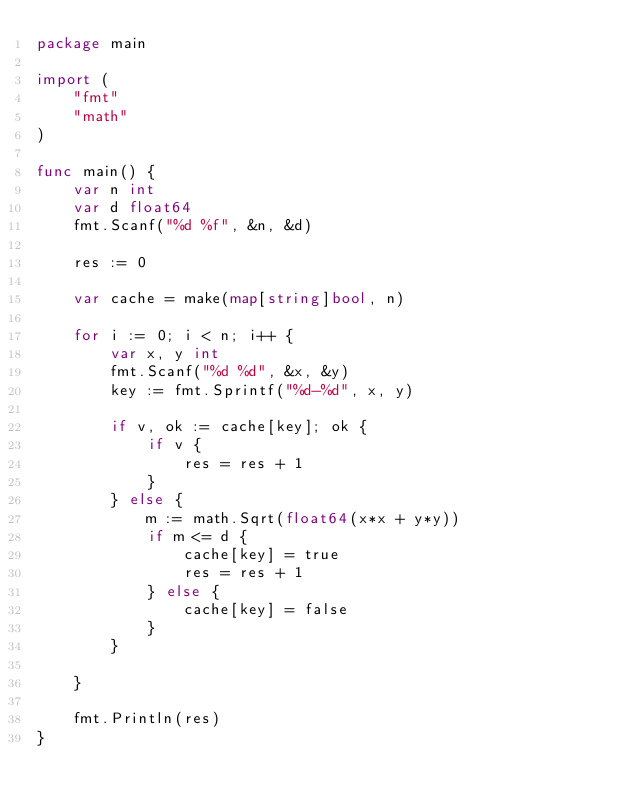Convert code to text. <code><loc_0><loc_0><loc_500><loc_500><_Go_>package main

import (
	"fmt"
	"math"
)

func main() {
	var n int
	var d float64
	fmt.Scanf("%d %f", &n, &d)

	res := 0

	var cache = make(map[string]bool, n)

	for i := 0; i < n; i++ {
		var x, y int
		fmt.Scanf("%d %d", &x, &y)
		key := fmt.Sprintf("%d-%d", x, y)

		if v, ok := cache[key]; ok {
			if v {
				res = res + 1
			}
		} else {
			m := math.Sqrt(float64(x*x + y*y))
			if m <= d {
				cache[key] = true
				res = res + 1
			} else {
				cache[key] = false
			}
		}

	}

	fmt.Println(res)
}
</code> 